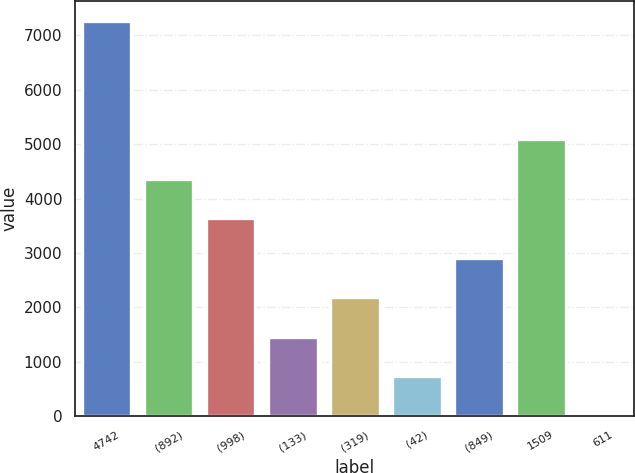Convert chart. <chart><loc_0><loc_0><loc_500><loc_500><bar_chart><fcel>4742<fcel>(892)<fcel>(998)<fcel>(133)<fcel>(319)<fcel>(42)<fcel>(849)<fcel>1509<fcel>611<nl><fcel>7262<fcel>4360.12<fcel>3634.66<fcel>1458.28<fcel>2183.74<fcel>732.82<fcel>2909.2<fcel>5085.58<fcel>7.36<nl></chart> 